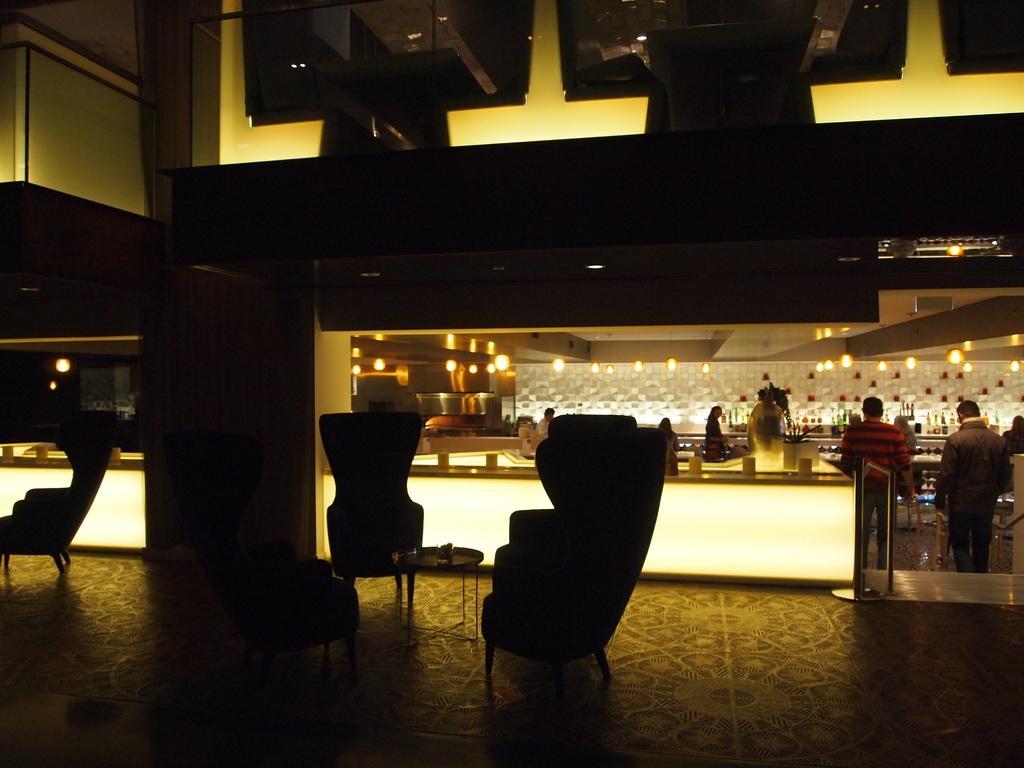Could you give a brief overview of what you see in this image? In this image there are chairs, tables and a few people in the lobby of a restaurant. 